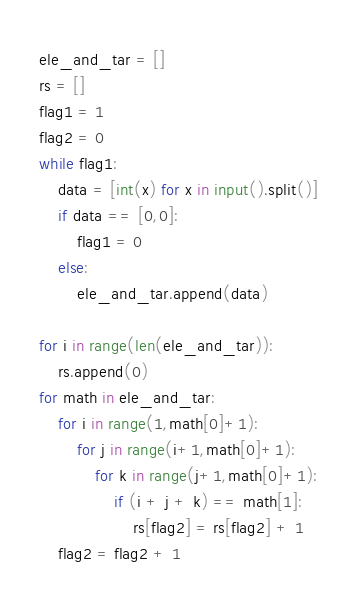Convert code to text. <code><loc_0><loc_0><loc_500><loc_500><_Python_>ele_and_tar = []
rs = []
flag1 = 1
flag2 = 0
while flag1:
    data = [int(x) for x in input().split()]
    if data == [0,0]:
        flag1 = 0
    else:
        ele_and_tar.append(data)
        
for i in range(len(ele_and_tar)):
    rs.append(0)
for math in ele_and_tar:
    for i in range(1,math[0]+1):
        for j in range(i+1,math[0]+1):
            for k in range(j+1,math[0]+1):
                if (i + j + k) == math[1]:
                    rs[flag2] = rs[flag2] + 1
    flag2 = flag2 + 1
</code> 